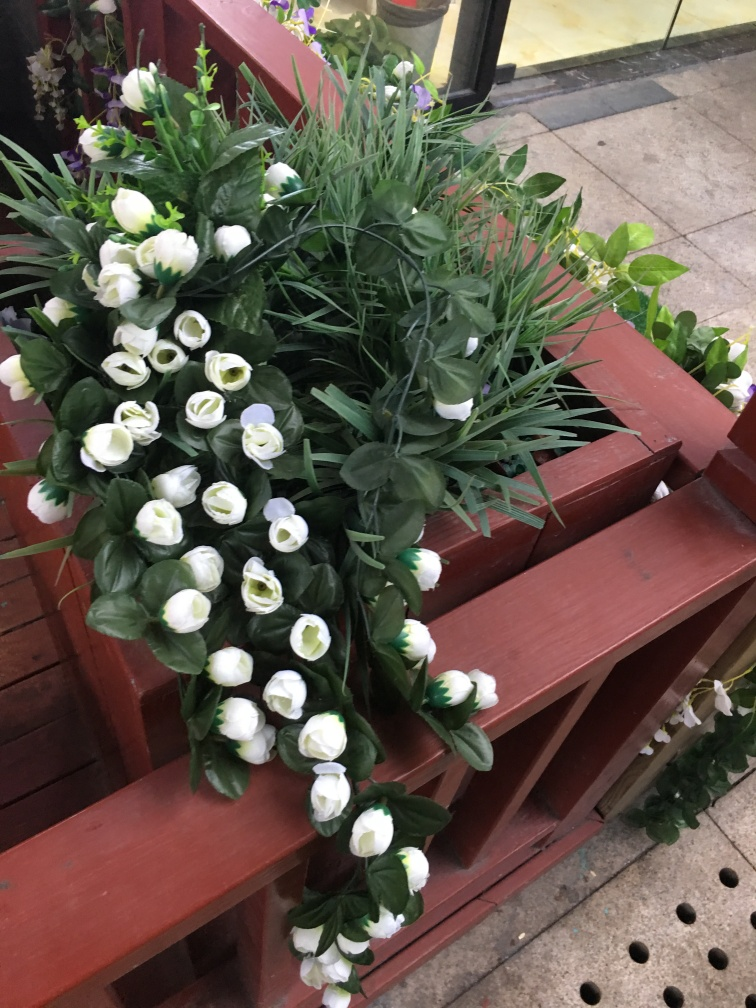Describe the setting where these artificial plants are placed. The artificial plants are neatly arranged on a multi-tiered wooden shelving unit, which adds a rustic charm. This kind of setup suggests a setting that could be either an indoor space like a florist's shop where plants and flowers are on display for sale, or part of a larger decorative installation in a commercial space or at a special event where artificial flora is used to enhance the ambience.  How could these artificial plants enhance the ambiance of a room? Artificial plants, such as these white tulips, can elevate a room's ambiance by adding a sense of freshness and natural beauty that's often associated with live greenery. They require no upkeep, making them convenient for spaces without natural light or for individuals who may not have the time to tend to real plants. They introduce a calming, serene vibe to any space and can soften the aesthetic of the room, making it feel more welcoming and vibrant. 